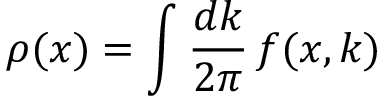<formula> <loc_0><loc_0><loc_500><loc_500>\rho ( x ) = \int \frac { d k } { 2 \pi } \, f ( x , k )</formula> 